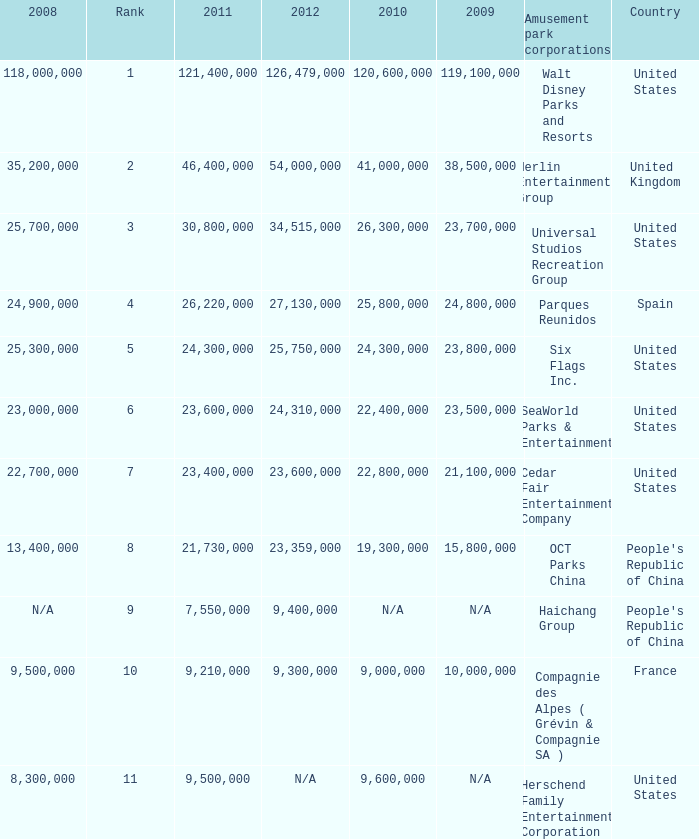In the United States the 2011 attendance at this amusement park corporation was larger than 30,800,000 but lists what as its 2008 attendance? 118000000.0. 